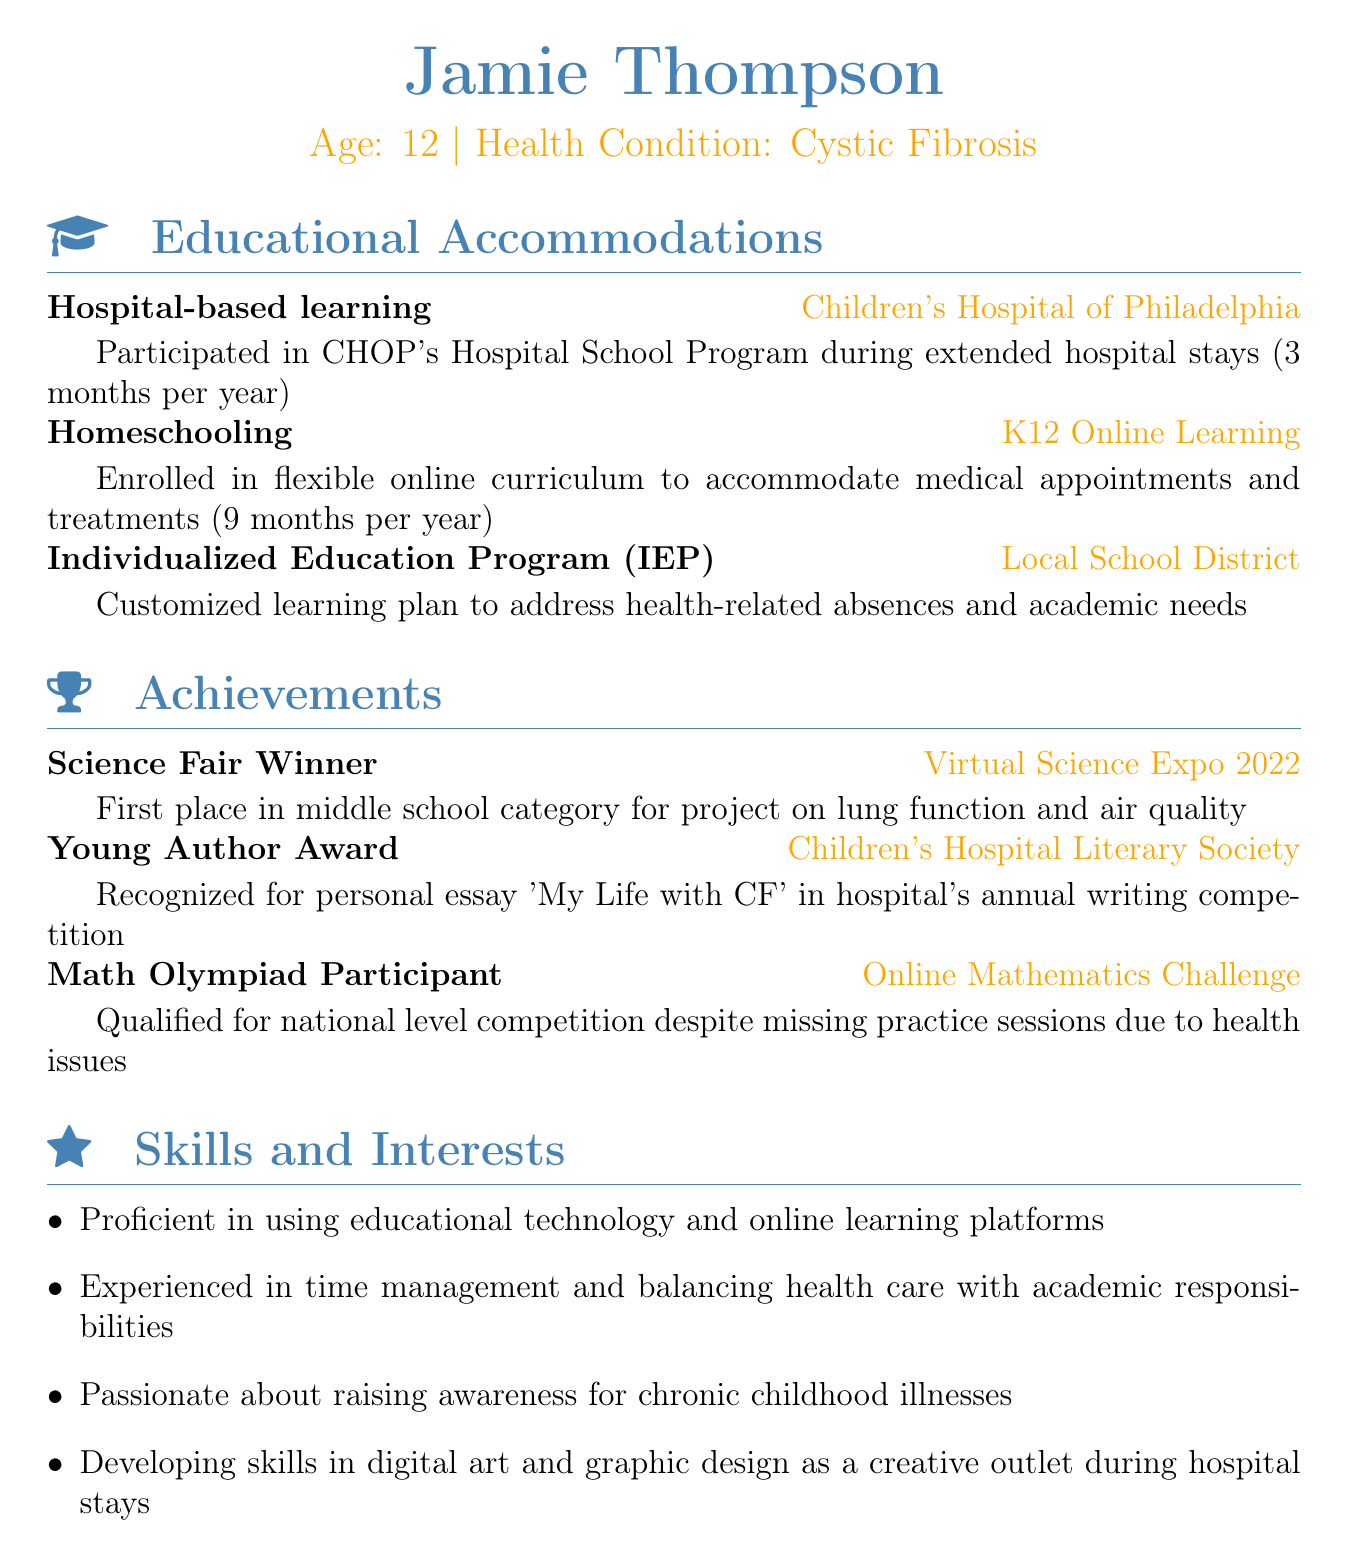What is the name of the student? The document states the name of the student at the beginning as Jamie Thompson.
Answer: Jamie Thompson How old is Jamie? Jamie's age is indicated in the personal information section as 12.
Answer: 12 What health condition does Jamie have? The health condition is specified in the personal information section, which mentions Cystic Fibrosis.
Answer: Cystic Fibrosis For how long does Jamie participate in hospital-based learning? The duration of participation in hospital-based learning is mentioned as 3 months per year.
Answer: 3 months per year What online learning program is Jamie enrolled in? The educational accommodation section indicates that Jamie is enrolled in K12 Online Learning.
Answer: K12 Online Learning What achievement did Jamie receive for their project in the Virtual Science Expo 2022? Jamie won first place in the middle school category for a project on lung function and air quality.
Answer: First place What award did Jamie win for their personal essay? The document states that Jamie received the Young Author Award.
Answer: Young Author Award Which competition did Jamie qualify for despite health issues? The document notes Jamie qualified for the national level Math Olympiad competition.
Answer: Math Olympiad What skill is Jamie developing during hospital stays? The document mentions that Jamie is developing skills in digital art and graphic design as a creative outlet.
Answer: Digital art and graphic design 